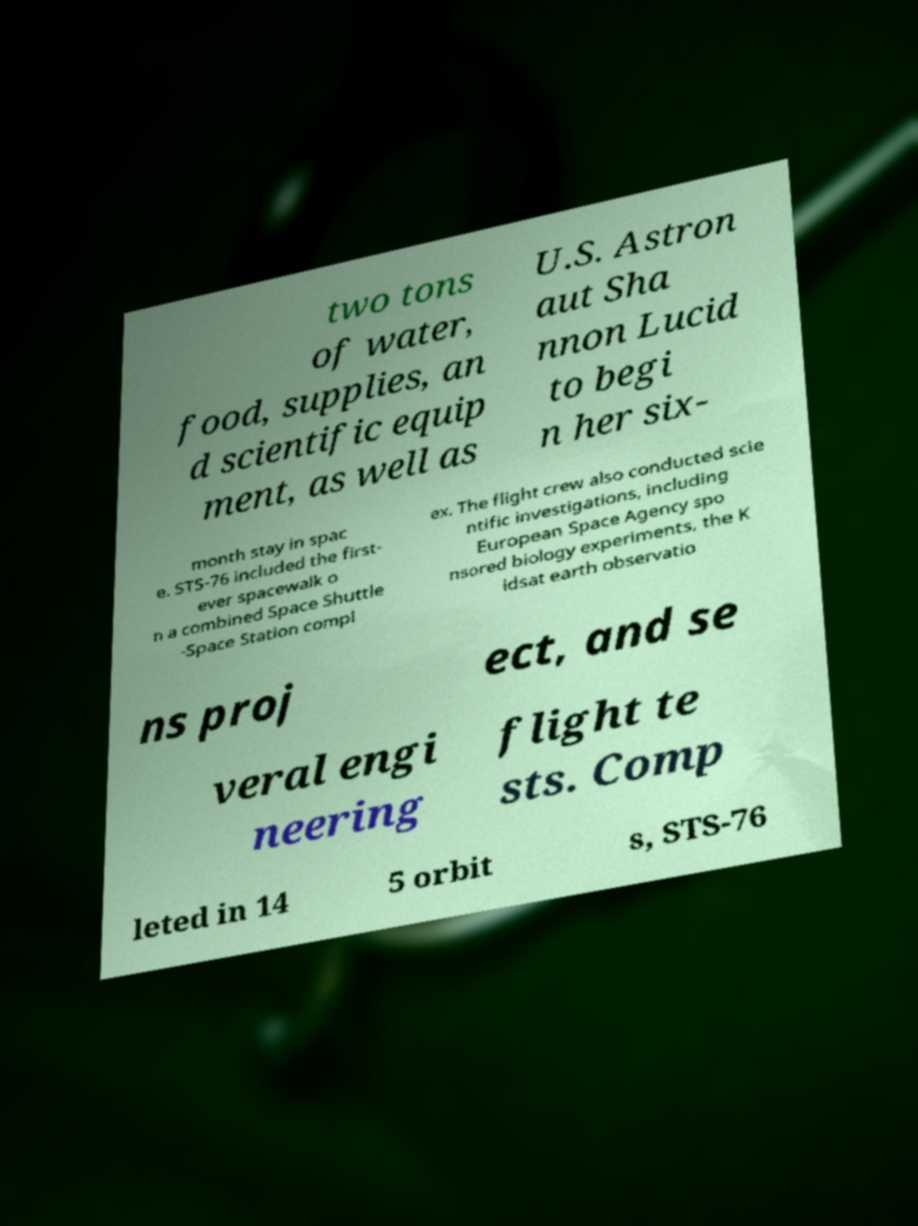Can you read and provide the text displayed in the image?This photo seems to have some interesting text. Can you extract and type it out for me? two tons of water, food, supplies, an d scientific equip ment, as well as U.S. Astron aut Sha nnon Lucid to begi n her six- month stay in spac e. STS-76 included the first- ever spacewalk o n a combined Space Shuttle -Space Station compl ex. The flight crew also conducted scie ntific investigations, including European Space Agency spo nsored biology experiments, the K idsat earth observatio ns proj ect, and se veral engi neering flight te sts. Comp leted in 14 5 orbit s, STS-76 